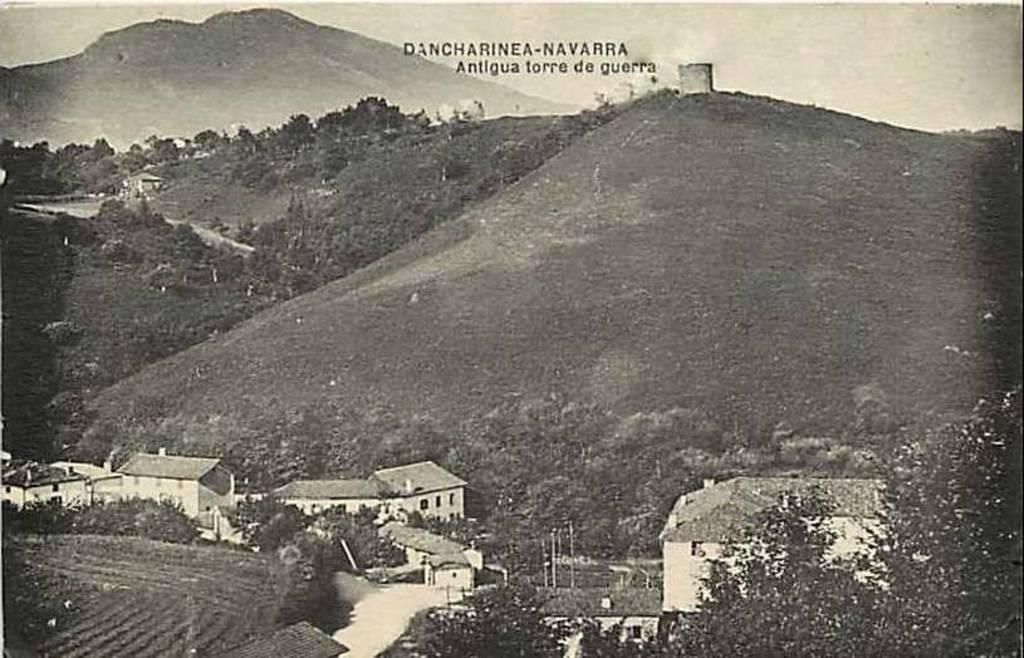What is the color scheme of the image? The image is black and white. What type of landscape can be seen in the image? There are hills with trees in the image. What structures are present at the bottom of the image? There are many buildings at the bottom of the image. What is written at the top of the image? There is something written at the top of the image. What part of the natural environment is visible in the image? The sky is visible in the image. Can you tell me how many people are talking in the park in the image? There is no park or people talking in the image; it features a black and white landscape with hills, trees, buildings, and sky. 